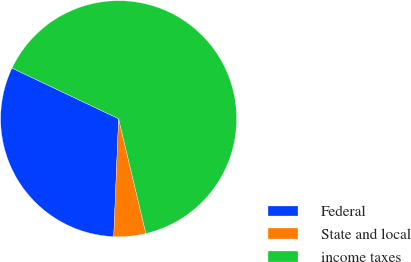<chart> <loc_0><loc_0><loc_500><loc_500><pie_chart><fcel>Federal<fcel>State and local<fcel>income taxes<nl><fcel>31.39%<fcel>4.37%<fcel>64.24%<nl></chart> 